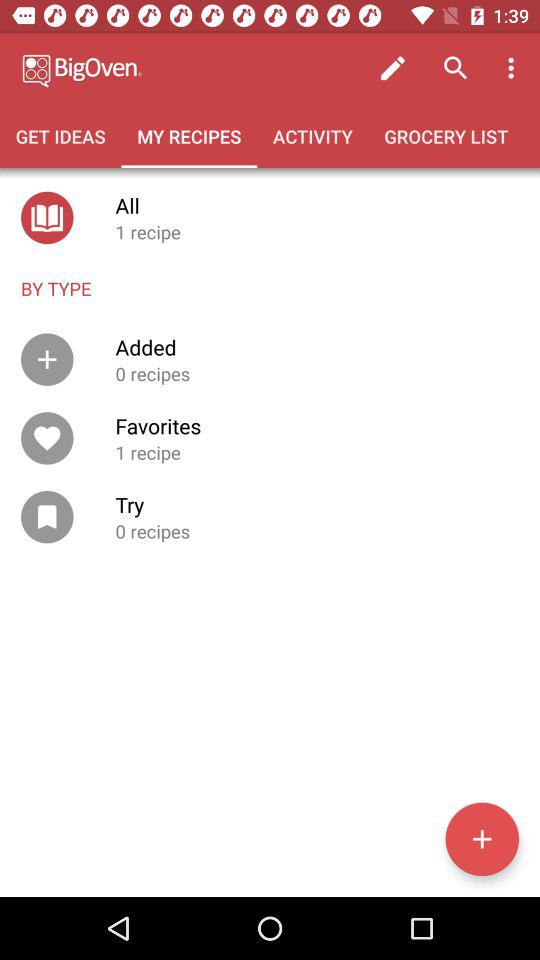How many more recipes are in my favorites than in my added recipes? 1 